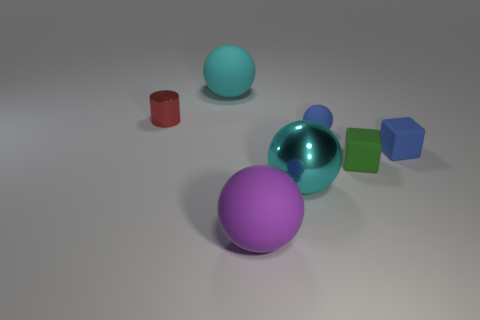What size is the matte sphere that is the same color as the large shiny object?
Provide a succinct answer. Large. There is a big rubber ball that is behind the metallic object that is right of the tiny metallic cylinder; what number of big cyan metallic objects are behind it?
Your response must be concise. 0. Is the color of the small rubber sphere the same as the big object behind the tiny metal object?
Give a very brief answer. No. There is a large rubber thing that is the same color as the large shiny sphere; what shape is it?
Keep it short and to the point. Sphere. There is a big cyan object that is in front of the cyan object behind the metal object that is behind the small blue cube; what is its material?
Make the answer very short. Metal. There is a large matte object that is behind the small red metal object; is it the same shape as the tiny metal thing?
Offer a very short reply. No. What is the cyan ball to the left of the purple object made of?
Give a very brief answer. Rubber. How many matte things are either yellow blocks or blue balls?
Give a very brief answer. 1. Are there any cubes that have the same size as the cyan metallic sphere?
Offer a terse response. No. Are there more tiny blue matte objects that are to the left of the cyan rubber object than large blue things?
Your response must be concise. No. 